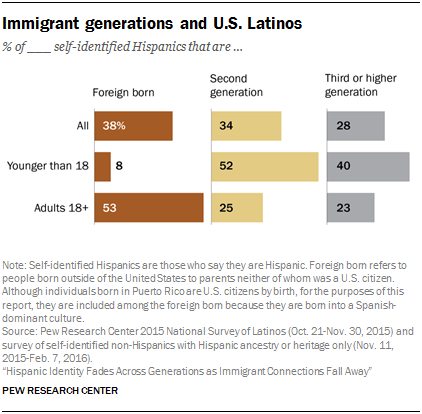List a handful of essential elements in this visual. The gray bar represents the third or higher generation of a particular thing. The difference between "Foreign-born younger than 18" and "Adults 18+ Foreign-born" is 45. 